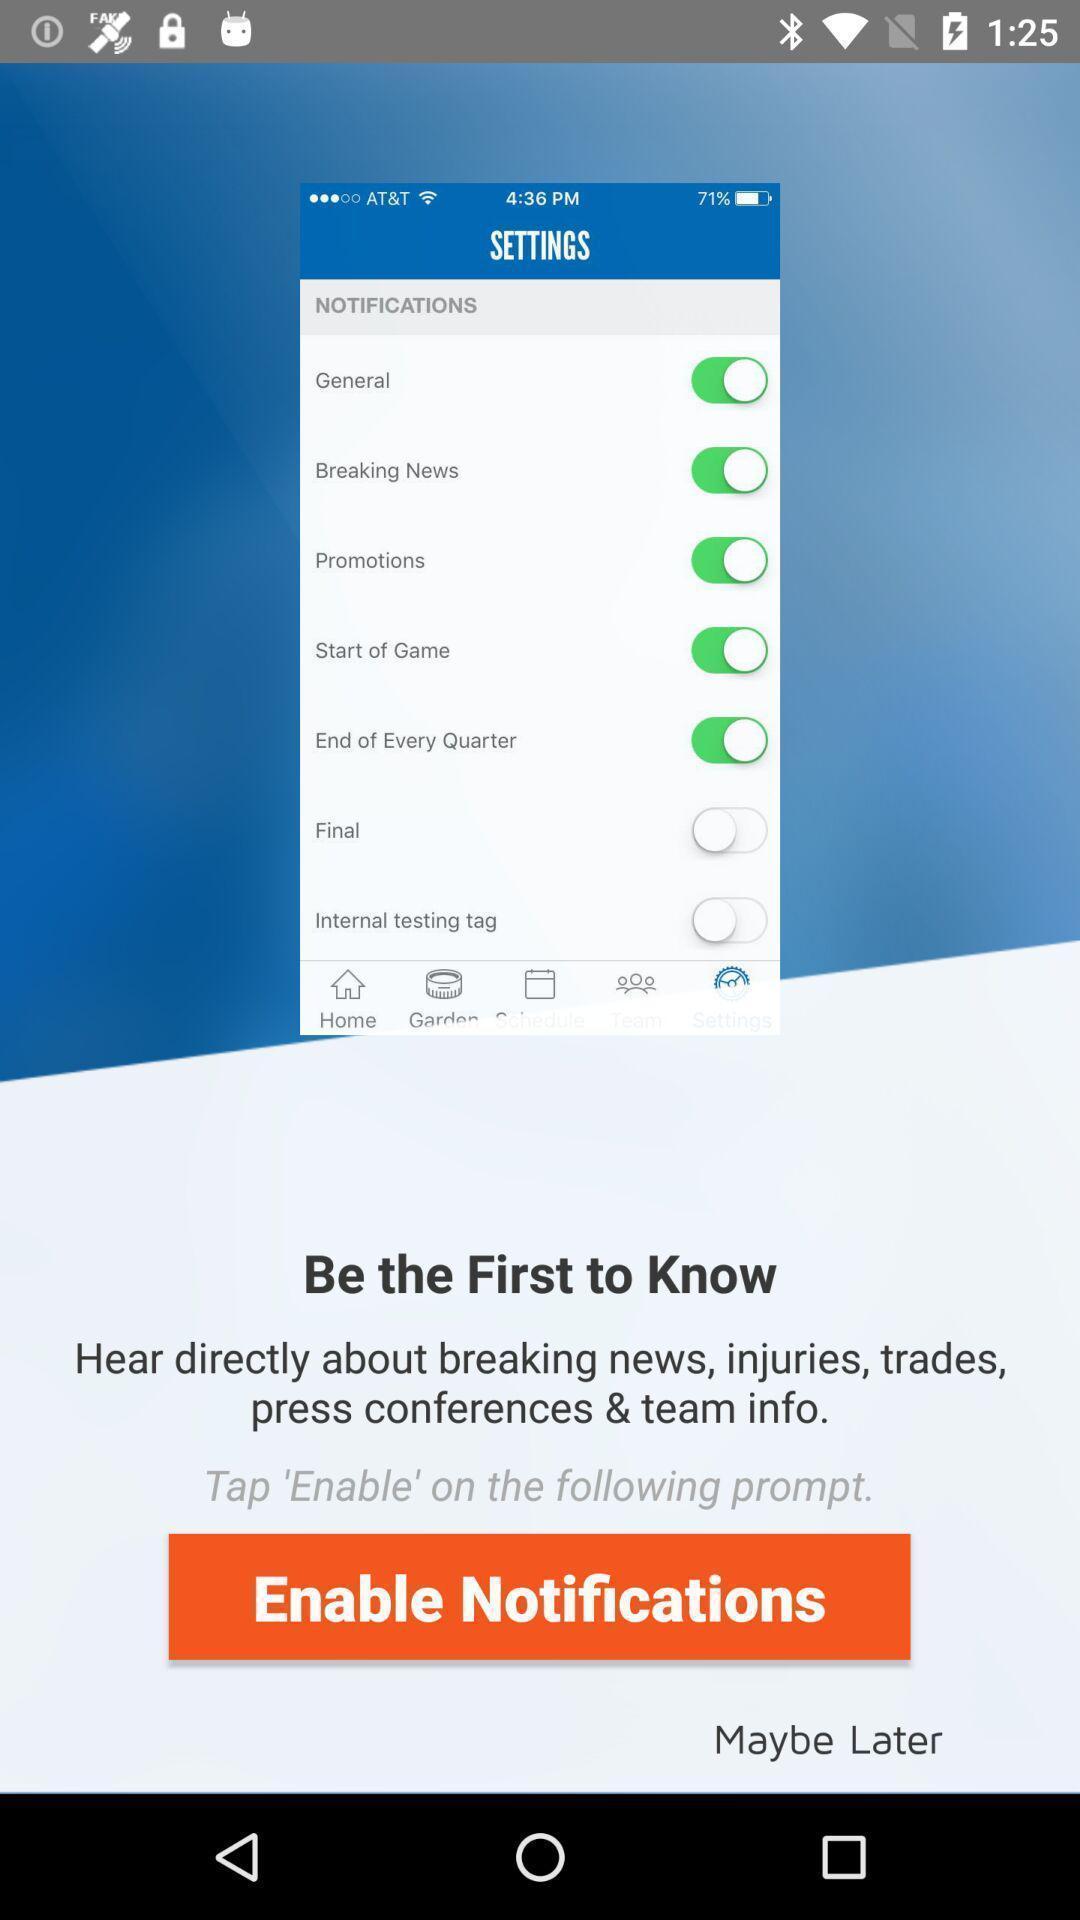Give me a narrative description of this picture. Screen showing be the first to know with enable notifications. 